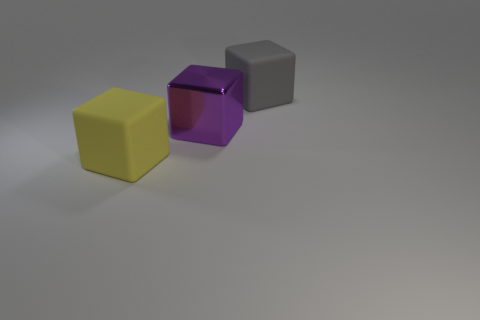Is there any other thing that is the same material as the large purple object?
Make the answer very short. No. There is a purple thing that is in front of the big gray block; what is it made of?
Make the answer very short. Metal. The large thing that is to the right of the yellow rubber block and left of the big gray thing has what shape?
Keep it short and to the point. Cube. What material is the large purple block?
Provide a succinct answer. Metal. What number of cubes are either large purple metallic objects or yellow matte things?
Give a very brief answer. 2. Is the material of the big purple cube the same as the large yellow cube?
Offer a terse response. No. What is the size of the yellow rubber thing that is the same shape as the large gray rubber thing?
Make the answer very short. Large. There is a big block that is in front of the large gray rubber cube and behind the big yellow object; what material is it?
Your answer should be compact. Metal. Are there an equal number of purple metal things in front of the large purple cube and large matte balls?
Give a very brief answer. Yes. How many objects are either big blocks left of the large metal thing or tiny green rubber cylinders?
Your answer should be compact. 1. 